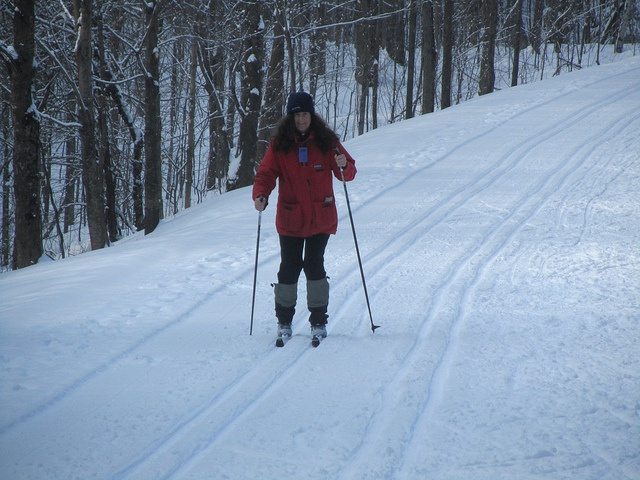Describe the objects in this image and their specific colors. I can see people in purple, black, maroon, darkblue, and gray tones and skis in purple, gray, and black tones in this image. 